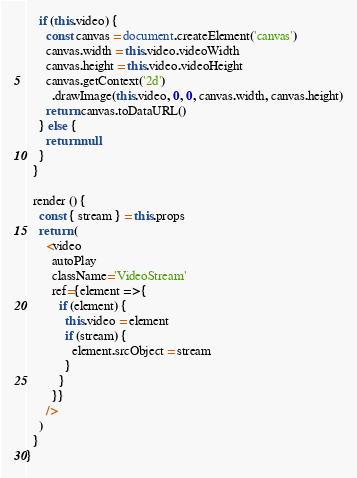<code> <loc_0><loc_0><loc_500><loc_500><_JavaScript_>    if (this.video) {
      const canvas = document.createElement('canvas')
      canvas.width = this.video.videoWidth
      canvas.height = this.video.videoHeight
      canvas.getContext('2d')
        .drawImage(this.video, 0, 0, canvas.width, canvas.height)
      return canvas.toDataURL()
    } else {
      return null
    }
  }

  render () {
    const { stream } = this.props
    return (
      <video
        autoPlay
        className='VideoStream'
        ref={element => {
          if (element) {
            this.video = element
            if (stream) {
              element.srcObject = stream
            }
          }
        }}
      />
    )
  }
}
</code> 